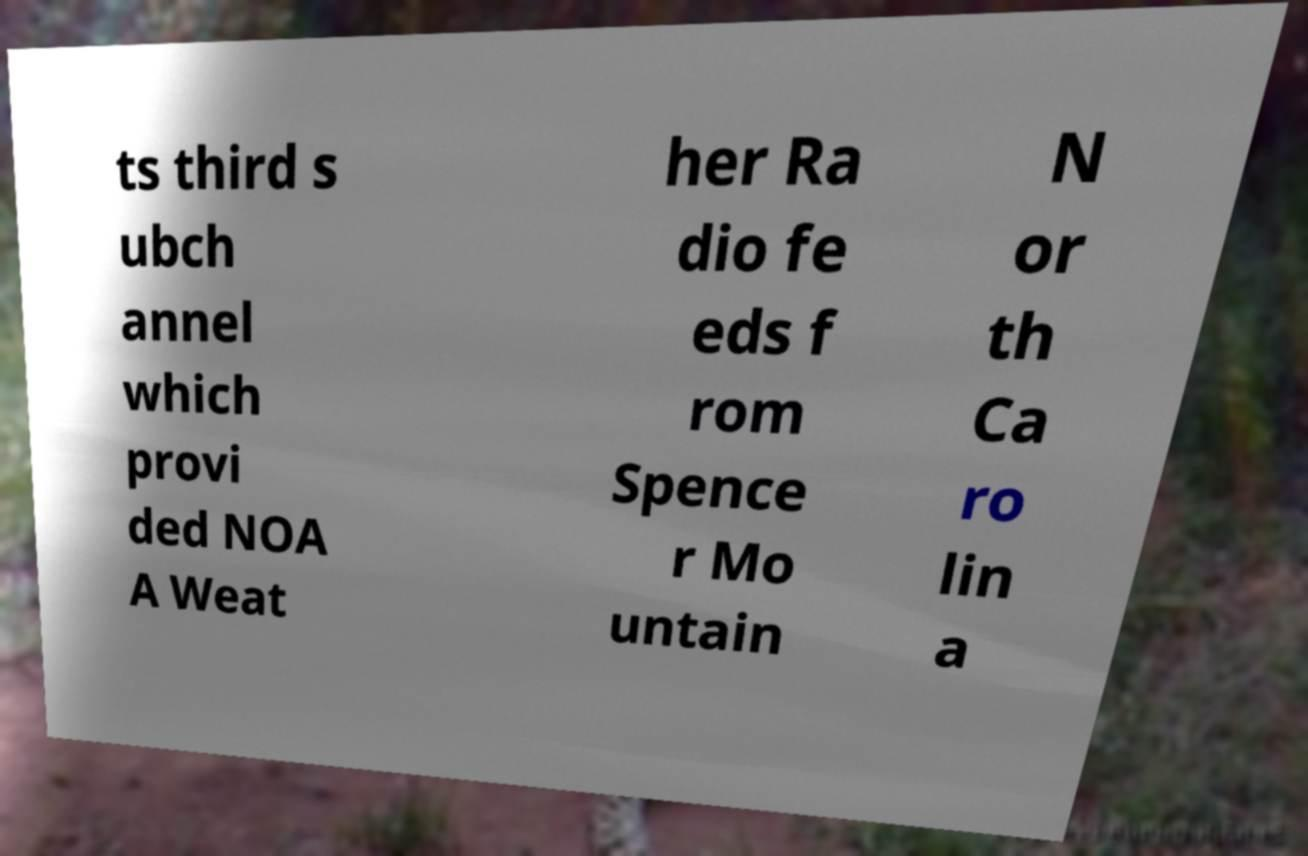Please identify and transcribe the text found in this image. ts third s ubch annel which provi ded NOA A Weat her Ra dio fe eds f rom Spence r Mo untain N or th Ca ro lin a 